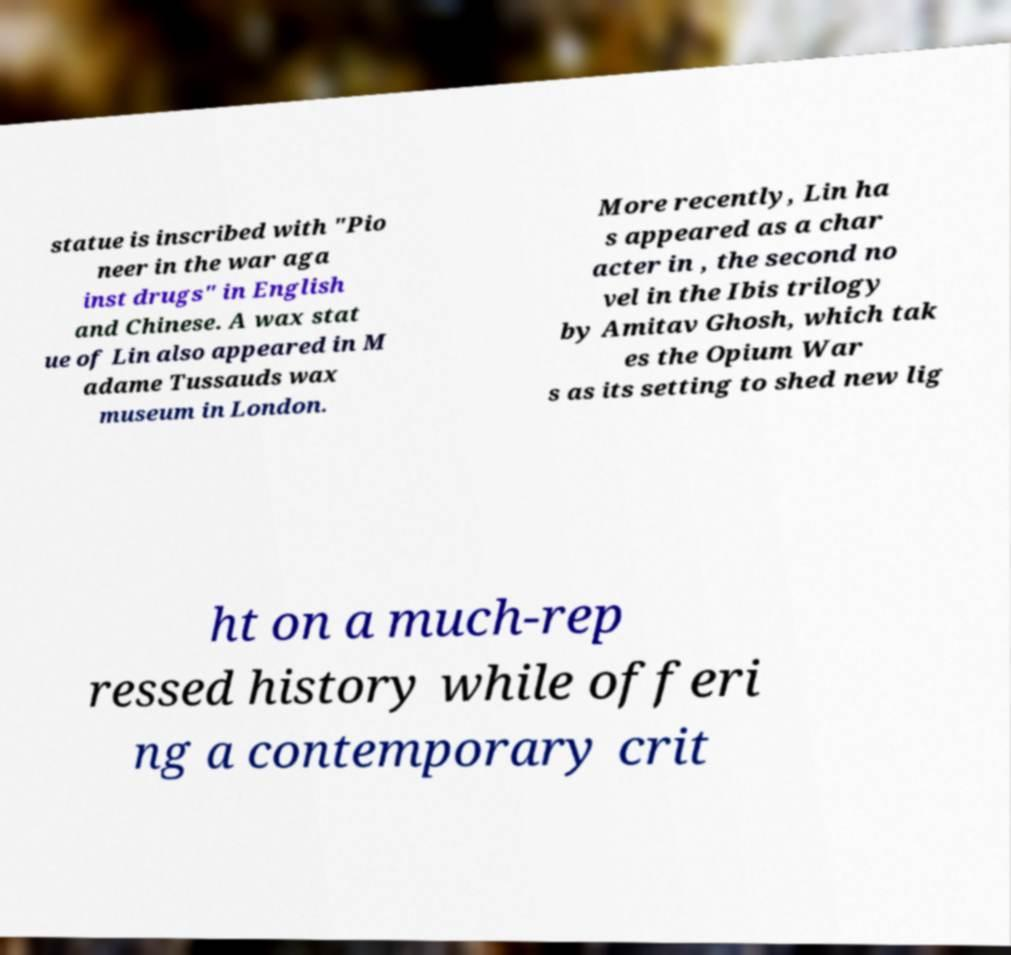I need the written content from this picture converted into text. Can you do that? statue is inscribed with "Pio neer in the war aga inst drugs" in English and Chinese. A wax stat ue of Lin also appeared in M adame Tussauds wax museum in London. More recently, Lin ha s appeared as a char acter in , the second no vel in the Ibis trilogy by Amitav Ghosh, which tak es the Opium War s as its setting to shed new lig ht on a much-rep ressed history while offeri ng a contemporary crit 